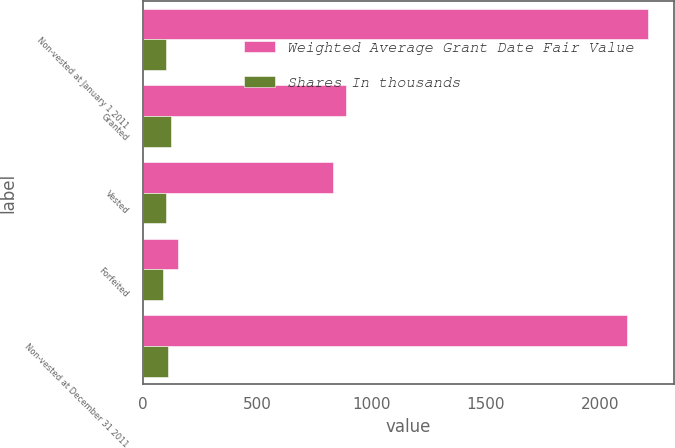Convert chart to OTSL. <chart><loc_0><loc_0><loc_500><loc_500><stacked_bar_chart><ecel><fcel>Non-vested at January 1 2011<fcel>Granted<fcel>Vested<fcel>Forfeited<fcel>Non-vested at December 31 2011<nl><fcel>Weighted Average Grant Date Fair Value<fcel>2210<fcel>888<fcel>829<fcel>154<fcel>2115<nl><fcel>Shares In thousands<fcel>100.72<fcel>124.16<fcel>102.12<fcel>86.61<fcel>109.31<nl></chart> 